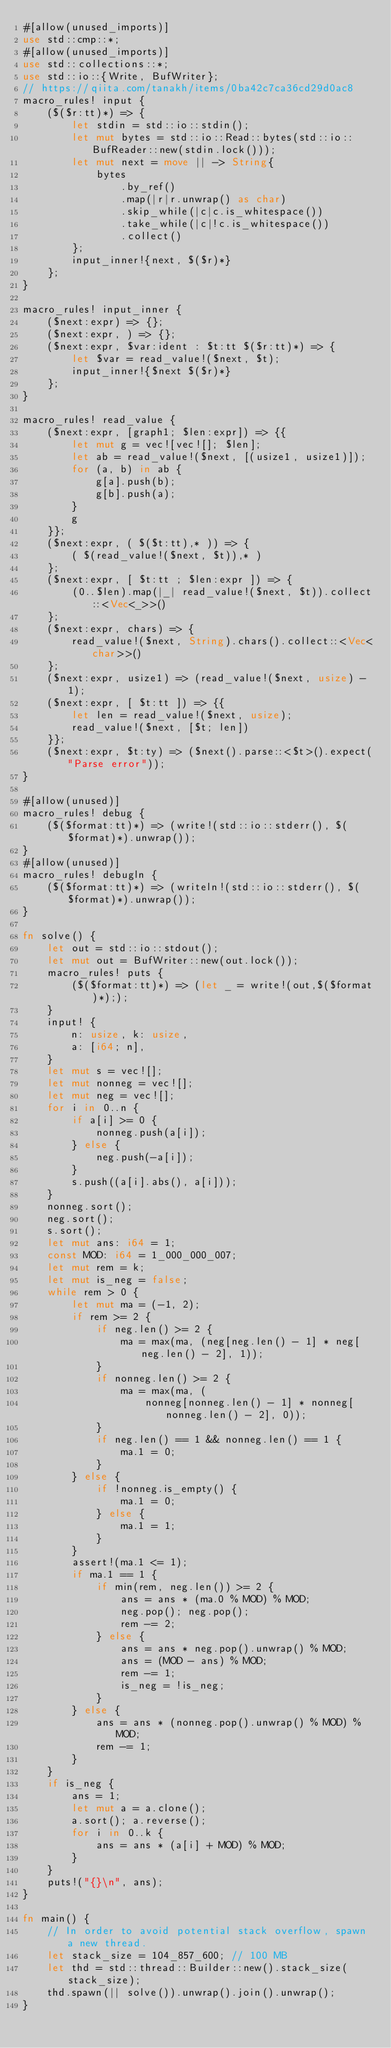<code> <loc_0><loc_0><loc_500><loc_500><_Rust_>#[allow(unused_imports)]
use std::cmp::*;
#[allow(unused_imports)]
use std::collections::*;
use std::io::{Write, BufWriter};
// https://qiita.com/tanakh/items/0ba42c7ca36cd29d0ac8
macro_rules! input {
    ($($r:tt)*) => {
        let stdin = std::io::stdin();
        let mut bytes = std::io::Read::bytes(std::io::BufReader::new(stdin.lock()));
        let mut next = move || -> String{
            bytes
                .by_ref()
                .map(|r|r.unwrap() as char)
                .skip_while(|c|c.is_whitespace())
                .take_while(|c|!c.is_whitespace())
                .collect()
        };
        input_inner!{next, $($r)*}
    };
}

macro_rules! input_inner {
    ($next:expr) => {};
    ($next:expr, ) => {};
    ($next:expr, $var:ident : $t:tt $($r:tt)*) => {
        let $var = read_value!($next, $t);
        input_inner!{$next $($r)*}
    };
}

macro_rules! read_value {
    ($next:expr, [graph1; $len:expr]) => {{
        let mut g = vec![vec![]; $len];
        let ab = read_value!($next, [(usize1, usize1)]);
        for (a, b) in ab {
            g[a].push(b);
            g[b].push(a);
        }
        g
    }};
    ($next:expr, ( $($t:tt),* )) => {
        ( $(read_value!($next, $t)),* )
    };
    ($next:expr, [ $t:tt ; $len:expr ]) => {
        (0..$len).map(|_| read_value!($next, $t)).collect::<Vec<_>>()
    };
    ($next:expr, chars) => {
        read_value!($next, String).chars().collect::<Vec<char>>()
    };
    ($next:expr, usize1) => (read_value!($next, usize) - 1);
    ($next:expr, [ $t:tt ]) => {{
        let len = read_value!($next, usize);
        read_value!($next, [$t; len])
    }};
    ($next:expr, $t:ty) => ($next().parse::<$t>().expect("Parse error"));
}

#[allow(unused)]
macro_rules! debug {
    ($($format:tt)*) => (write!(std::io::stderr(), $($format)*).unwrap());
}
#[allow(unused)]
macro_rules! debugln {
    ($($format:tt)*) => (writeln!(std::io::stderr(), $($format)*).unwrap());
}

fn solve() {
    let out = std::io::stdout();
    let mut out = BufWriter::new(out.lock());
    macro_rules! puts {
        ($($format:tt)*) => (let _ = write!(out,$($format)*););
    }
    input! {
        n: usize, k: usize,
        a: [i64; n],
    }
    let mut s = vec![];
    let mut nonneg = vec![];
    let mut neg = vec![];
    for i in 0..n {
        if a[i] >= 0 {
            nonneg.push(a[i]);
        } else {
            neg.push(-a[i]);
        }
        s.push((a[i].abs(), a[i]));
    }
    nonneg.sort();
    neg.sort();
    s.sort();
    let mut ans: i64 = 1;
    const MOD: i64 = 1_000_000_007;
    let mut rem = k;
    let mut is_neg = false;
    while rem > 0 {
        let mut ma = (-1, 2);
        if rem >= 2 {
            if neg.len() >= 2 {
                ma = max(ma, (neg[neg.len() - 1] * neg[neg.len() - 2], 1));
            }
            if nonneg.len() >= 2 {
                ma = max(ma, (
                    nonneg[nonneg.len() - 1] * nonneg[nonneg.len() - 2], 0));
            }
            if neg.len() == 1 && nonneg.len() == 1 {
                ma.1 = 0;
            }
        } else {
            if !nonneg.is_empty() {
                ma.1 = 0;
            } else {
                ma.1 = 1;
            }
        }
        assert!(ma.1 <= 1);
        if ma.1 == 1 {
            if min(rem, neg.len()) >= 2 {
                ans = ans * (ma.0 % MOD) % MOD;
                neg.pop(); neg.pop();
                rem -= 2;
            } else {
                ans = ans * neg.pop().unwrap() % MOD;
                ans = (MOD - ans) % MOD;
                rem -= 1;
                is_neg = !is_neg;
            }
        } else {
            ans = ans * (nonneg.pop().unwrap() % MOD) % MOD;
            rem -= 1;
        }
    }
    if is_neg {
        ans = 1;
        let mut a = a.clone();
        a.sort(); a.reverse();
        for i in 0..k {
            ans = ans * (a[i] + MOD) % MOD;
        }
    }
    puts!("{}\n", ans);
}

fn main() {
    // In order to avoid potential stack overflow, spawn a new thread.
    let stack_size = 104_857_600; // 100 MB
    let thd = std::thread::Builder::new().stack_size(stack_size);
    thd.spawn(|| solve()).unwrap().join().unwrap();
}
</code> 